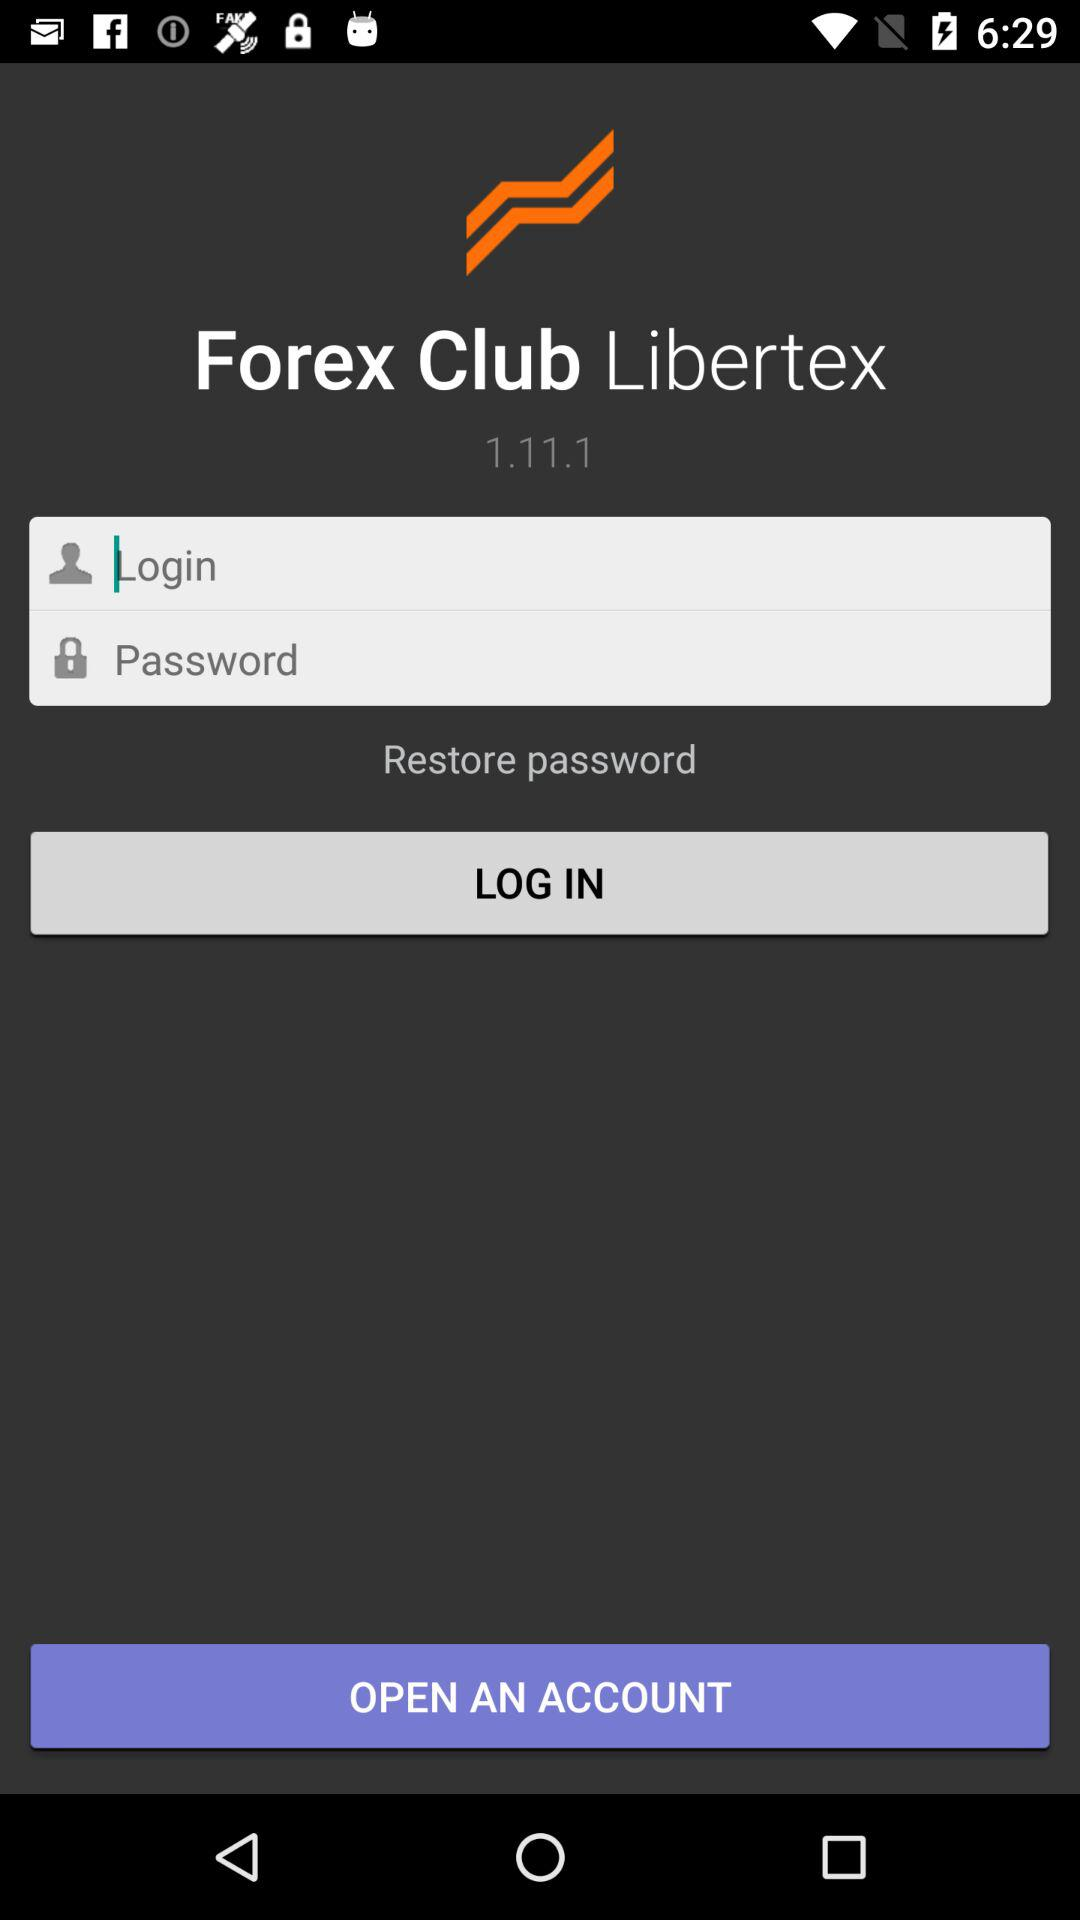What is the application name? The application name is "Forex Club Libertex". 